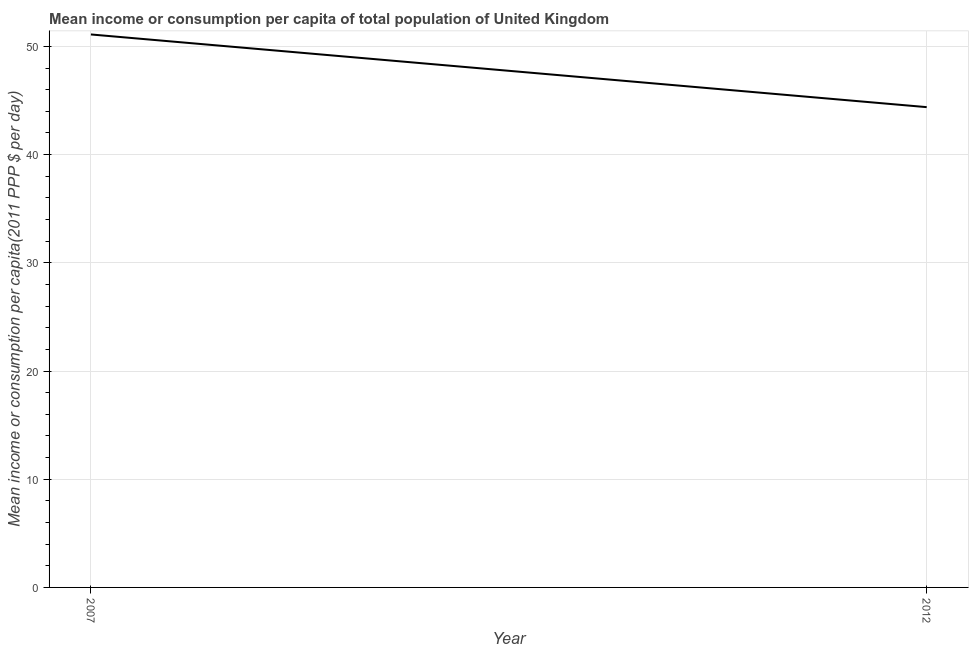What is the mean income or consumption in 2007?
Provide a short and direct response. 51.1. Across all years, what is the maximum mean income or consumption?
Give a very brief answer. 51.1. Across all years, what is the minimum mean income or consumption?
Keep it short and to the point. 44.38. What is the sum of the mean income or consumption?
Your response must be concise. 95.49. What is the difference between the mean income or consumption in 2007 and 2012?
Provide a succinct answer. 6.72. What is the average mean income or consumption per year?
Ensure brevity in your answer.  47.74. What is the median mean income or consumption?
Offer a very short reply. 47.74. In how many years, is the mean income or consumption greater than 22 $?
Offer a very short reply. 2. What is the ratio of the mean income or consumption in 2007 to that in 2012?
Your answer should be compact. 1.15. Does the mean income or consumption monotonically increase over the years?
Make the answer very short. No. Are the values on the major ticks of Y-axis written in scientific E-notation?
Offer a very short reply. No. Does the graph contain any zero values?
Your response must be concise. No. Does the graph contain grids?
Your answer should be compact. Yes. What is the title of the graph?
Your answer should be compact. Mean income or consumption per capita of total population of United Kingdom. What is the label or title of the X-axis?
Your answer should be compact. Year. What is the label or title of the Y-axis?
Offer a very short reply. Mean income or consumption per capita(2011 PPP $ per day). What is the Mean income or consumption per capita(2011 PPP $ per day) of 2007?
Offer a very short reply. 51.1. What is the Mean income or consumption per capita(2011 PPP $ per day) of 2012?
Make the answer very short. 44.38. What is the difference between the Mean income or consumption per capita(2011 PPP $ per day) in 2007 and 2012?
Offer a terse response. 6.72. What is the ratio of the Mean income or consumption per capita(2011 PPP $ per day) in 2007 to that in 2012?
Your answer should be compact. 1.15. 